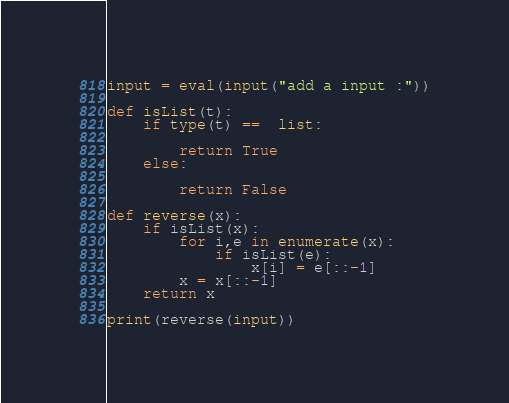Convert code to text. <code><loc_0><loc_0><loc_500><loc_500><_Python_>
input = eval(input("add a input :"))

def isList(t):
    if type(t) ==  list:
        
        return True
    else:
        
        return False

def reverse(x):
    if isList(x):
        for i,e in enumerate(x):
            if isList(e):
                x[i] = e[::-1]
        x = x[::-1]
    return x

print(reverse(input))

</code> 